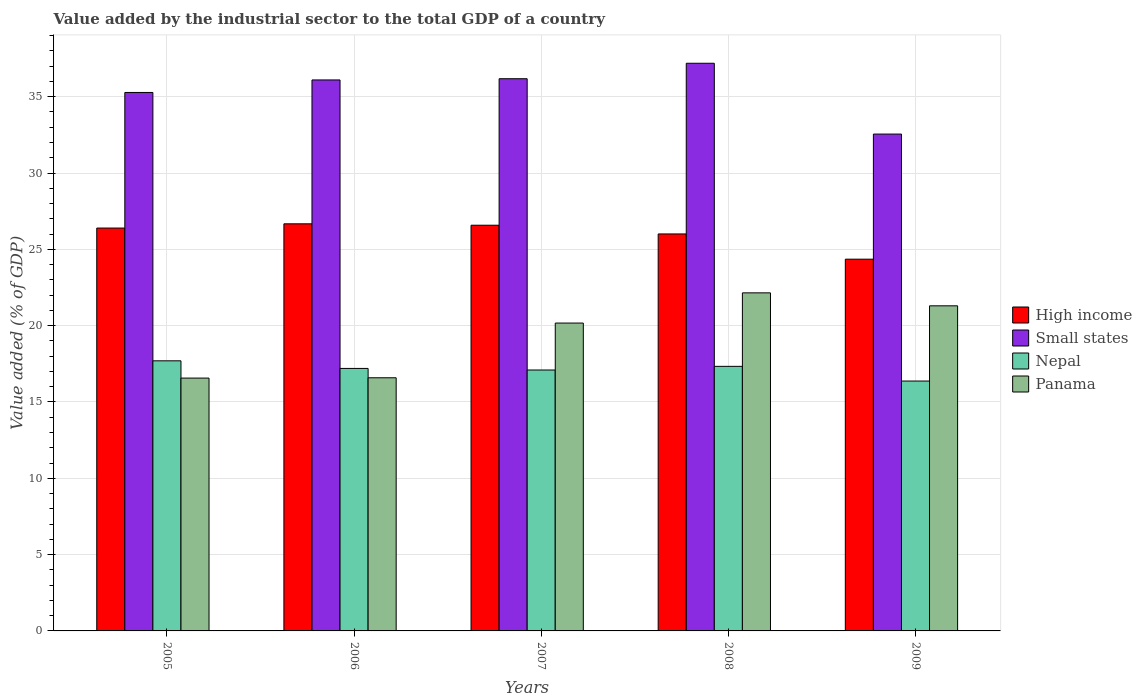How many different coloured bars are there?
Make the answer very short. 4. How many groups of bars are there?
Your answer should be very brief. 5. Are the number of bars per tick equal to the number of legend labels?
Your answer should be compact. Yes. Are the number of bars on each tick of the X-axis equal?
Make the answer very short. Yes. How many bars are there on the 1st tick from the left?
Your response must be concise. 4. What is the label of the 3rd group of bars from the left?
Provide a succinct answer. 2007. What is the value added by the industrial sector to the total GDP in Nepal in 2006?
Your response must be concise. 17.2. Across all years, what is the maximum value added by the industrial sector to the total GDP in Panama?
Give a very brief answer. 22.15. Across all years, what is the minimum value added by the industrial sector to the total GDP in Small states?
Offer a terse response. 32.55. In which year was the value added by the industrial sector to the total GDP in Small states maximum?
Your answer should be very brief. 2008. In which year was the value added by the industrial sector to the total GDP in High income minimum?
Give a very brief answer. 2009. What is the total value added by the industrial sector to the total GDP in Panama in the graph?
Ensure brevity in your answer.  96.77. What is the difference between the value added by the industrial sector to the total GDP in Panama in 2006 and that in 2009?
Your answer should be very brief. -4.71. What is the difference between the value added by the industrial sector to the total GDP in Panama in 2007 and the value added by the industrial sector to the total GDP in High income in 2005?
Offer a terse response. -6.22. What is the average value added by the industrial sector to the total GDP in High income per year?
Offer a very short reply. 26. In the year 2007, what is the difference between the value added by the industrial sector to the total GDP in Panama and value added by the industrial sector to the total GDP in High income?
Offer a terse response. -6.41. What is the ratio of the value added by the industrial sector to the total GDP in High income in 2006 to that in 2007?
Give a very brief answer. 1. Is the difference between the value added by the industrial sector to the total GDP in Panama in 2006 and 2009 greater than the difference between the value added by the industrial sector to the total GDP in High income in 2006 and 2009?
Your answer should be very brief. No. What is the difference between the highest and the second highest value added by the industrial sector to the total GDP in Small states?
Your answer should be very brief. 1.01. What is the difference between the highest and the lowest value added by the industrial sector to the total GDP in High income?
Provide a short and direct response. 2.32. In how many years, is the value added by the industrial sector to the total GDP in High income greater than the average value added by the industrial sector to the total GDP in High income taken over all years?
Provide a succinct answer. 4. Is the sum of the value added by the industrial sector to the total GDP in Panama in 2006 and 2009 greater than the maximum value added by the industrial sector to the total GDP in Nepal across all years?
Provide a short and direct response. Yes. What does the 3rd bar from the left in 2009 represents?
Your response must be concise. Nepal. What does the 3rd bar from the right in 2005 represents?
Offer a terse response. Small states. How many bars are there?
Offer a terse response. 20. How many years are there in the graph?
Keep it short and to the point. 5. Are the values on the major ticks of Y-axis written in scientific E-notation?
Your answer should be compact. No. Does the graph contain any zero values?
Offer a very short reply. No. Does the graph contain grids?
Keep it short and to the point. Yes. Where does the legend appear in the graph?
Offer a very short reply. Center right. How are the legend labels stacked?
Offer a terse response. Vertical. What is the title of the graph?
Your response must be concise. Value added by the industrial sector to the total GDP of a country. Does "Ethiopia" appear as one of the legend labels in the graph?
Your response must be concise. No. What is the label or title of the X-axis?
Keep it short and to the point. Years. What is the label or title of the Y-axis?
Make the answer very short. Value added (% of GDP). What is the Value added (% of GDP) of High income in 2005?
Offer a very short reply. 26.39. What is the Value added (% of GDP) of Small states in 2005?
Make the answer very short. 35.28. What is the Value added (% of GDP) of Nepal in 2005?
Make the answer very short. 17.7. What is the Value added (% of GDP) of Panama in 2005?
Offer a terse response. 16.56. What is the Value added (% of GDP) of High income in 2006?
Give a very brief answer. 26.67. What is the Value added (% of GDP) of Small states in 2006?
Provide a short and direct response. 36.1. What is the Value added (% of GDP) in Nepal in 2006?
Give a very brief answer. 17.2. What is the Value added (% of GDP) in Panama in 2006?
Provide a succinct answer. 16.58. What is the Value added (% of GDP) in High income in 2007?
Offer a terse response. 26.58. What is the Value added (% of GDP) in Small states in 2007?
Your answer should be compact. 36.18. What is the Value added (% of GDP) in Nepal in 2007?
Offer a very short reply. 17.09. What is the Value added (% of GDP) of Panama in 2007?
Make the answer very short. 20.17. What is the Value added (% of GDP) in High income in 2008?
Your answer should be compact. 26.01. What is the Value added (% of GDP) of Small states in 2008?
Offer a very short reply. 37.19. What is the Value added (% of GDP) of Nepal in 2008?
Keep it short and to the point. 17.33. What is the Value added (% of GDP) of Panama in 2008?
Provide a short and direct response. 22.15. What is the Value added (% of GDP) of High income in 2009?
Provide a succinct answer. 24.35. What is the Value added (% of GDP) in Small states in 2009?
Offer a very short reply. 32.55. What is the Value added (% of GDP) of Nepal in 2009?
Offer a very short reply. 16.37. What is the Value added (% of GDP) in Panama in 2009?
Keep it short and to the point. 21.3. Across all years, what is the maximum Value added (% of GDP) in High income?
Offer a terse response. 26.67. Across all years, what is the maximum Value added (% of GDP) in Small states?
Ensure brevity in your answer.  37.19. Across all years, what is the maximum Value added (% of GDP) of Nepal?
Provide a succinct answer. 17.7. Across all years, what is the maximum Value added (% of GDP) of Panama?
Ensure brevity in your answer.  22.15. Across all years, what is the minimum Value added (% of GDP) in High income?
Keep it short and to the point. 24.35. Across all years, what is the minimum Value added (% of GDP) of Small states?
Ensure brevity in your answer.  32.55. Across all years, what is the minimum Value added (% of GDP) in Nepal?
Make the answer very short. 16.37. Across all years, what is the minimum Value added (% of GDP) in Panama?
Your answer should be very brief. 16.56. What is the total Value added (% of GDP) of High income in the graph?
Your answer should be very brief. 130.01. What is the total Value added (% of GDP) in Small states in the graph?
Ensure brevity in your answer.  177.3. What is the total Value added (% of GDP) of Nepal in the graph?
Offer a terse response. 85.69. What is the total Value added (% of GDP) in Panama in the graph?
Make the answer very short. 96.77. What is the difference between the Value added (% of GDP) in High income in 2005 and that in 2006?
Offer a very short reply. -0.28. What is the difference between the Value added (% of GDP) of Small states in 2005 and that in 2006?
Offer a terse response. -0.82. What is the difference between the Value added (% of GDP) of Nepal in 2005 and that in 2006?
Your response must be concise. 0.5. What is the difference between the Value added (% of GDP) in Panama in 2005 and that in 2006?
Keep it short and to the point. -0.02. What is the difference between the Value added (% of GDP) in High income in 2005 and that in 2007?
Ensure brevity in your answer.  -0.19. What is the difference between the Value added (% of GDP) of Small states in 2005 and that in 2007?
Give a very brief answer. -0.9. What is the difference between the Value added (% of GDP) in Nepal in 2005 and that in 2007?
Make the answer very short. 0.6. What is the difference between the Value added (% of GDP) in Panama in 2005 and that in 2007?
Provide a succinct answer. -3.61. What is the difference between the Value added (% of GDP) in High income in 2005 and that in 2008?
Your answer should be very brief. 0.39. What is the difference between the Value added (% of GDP) in Small states in 2005 and that in 2008?
Your answer should be very brief. -1.91. What is the difference between the Value added (% of GDP) of Nepal in 2005 and that in 2008?
Offer a terse response. 0.36. What is the difference between the Value added (% of GDP) of Panama in 2005 and that in 2008?
Offer a terse response. -5.58. What is the difference between the Value added (% of GDP) of High income in 2005 and that in 2009?
Ensure brevity in your answer.  2.04. What is the difference between the Value added (% of GDP) of Small states in 2005 and that in 2009?
Offer a terse response. 2.73. What is the difference between the Value added (% of GDP) of Nepal in 2005 and that in 2009?
Provide a short and direct response. 1.32. What is the difference between the Value added (% of GDP) of Panama in 2005 and that in 2009?
Provide a short and direct response. -4.73. What is the difference between the Value added (% of GDP) in High income in 2006 and that in 2007?
Your response must be concise. 0.09. What is the difference between the Value added (% of GDP) of Small states in 2006 and that in 2007?
Provide a succinct answer. -0.08. What is the difference between the Value added (% of GDP) of Nepal in 2006 and that in 2007?
Provide a short and direct response. 0.1. What is the difference between the Value added (% of GDP) of Panama in 2006 and that in 2007?
Your answer should be compact. -3.59. What is the difference between the Value added (% of GDP) of High income in 2006 and that in 2008?
Your answer should be very brief. 0.66. What is the difference between the Value added (% of GDP) in Small states in 2006 and that in 2008?
Ensure brevity in your answer.  -1.09. What is the difference between the Value added (% of GDP) in Nepal in 2006 and that in 2008?
Offer a very short reply. -0.14. What is the difference between the Value added (% of GDP) of Panama in 2006 and that in 2008?
Offer a terse response. -5.56. What is the difference between the Value added (% of GDP) of High income in 2006 and that in 2009?
Your answer should be very brief. 2.32. What is the difference between the Value added (% of GDP) in Small states in 2006 and that in 2009?
Offer a very short reply. 3.55. What is the difference between the Value added (% of GDP) of Nepal in 2006 and that in 2009?
Offer a very short reply. 0.83. What is the difference between the Value added (% of GDP) of Panama in 2006 and that in 2009?
Your answer should be compact. -4.71. What is the difference between the Value added (% of GDP) in High income in 2007 and that in 2008?
Provide a short and direct response. 0.57. What is the difference between the Value added (% of GDP) in Small states in 2007 and that in 2008?
Provide a succinct answer. -1.01. What is the difference between the Value added (% of GDP) in Nepal in 2007 and that in 2008?
Your answer should be compact. -0.24. What is the difference between the Value added (% of GDP) of Panama in 2007 and that in 2008?
Your answer should be very brief. -1.98. What is the difference between the Value added (% of GDP) of High income in 2007 and that in 2009?
Your answer should be compact. 2.23. What is the difference between the Value added (% of GDP) of Small states in 2007 and that in 2009?
Give a very brief answer. 3.63. What is the difference between the Value added (% of GDP) in Nepal in 2007 and that in 2009?
Offer a terse response. 0.72. What is the difference between the Value added (% of GDP) in Panama in 2007 and that in 2009?
Your response must be concise. -1.13. What is the difference between the Value added (% of GDP) of High income in 2008 and that in 2009?
Ensure brevity in your answer.  1.65. What is the difference between the Value added (% of GDP) of Small states in 2008 and that in 2009?
Your answer should be very brief. 4.64. What is the difference between the Value added (% of GDP) of Nepal in 2008 and that in 2009?
Offer a terse response. 0.96. What is the difference between the Value added (% of GDP) in Panama in 2008 and that in 2009?
Ensure brevity in your answer.  0.85. What is the difference between the Value added (% of GDP) in High income in 2005 and the Value added (% of GDP) in Small states in 2006?
Provide a short and direct response. -9.7. What is the difference between the Value added (% of GDP) of High income in 2005 and the Value added (% of GDP) of Nepal in 2006?
Make the answer very short. 9.2. What is the difference between the Value added (% of GDP) in High income in 2005 and the Value added (% of GDP) in Panama in 2006?
Ensure brevity in your answer.  9.81. What is the difference between the Value added (% of GDP) in Small states in 2005 and the Value added (% of GDP) in Nepal in 2006?
Your answer should be compact. 18.08. What is the difference between the Value added (% of GDP) of Small states in 2005 and the Value added (% of GDP) of Panama in 2006?
Ensure brevity in your answer.  18.69. What is the difference between the Value added (% of GDP) in Nepal in 2005 and the Value added (% of GDP) in Panama in 2006?
Offer a very short reply. 1.11. What is the difference between the Value added (% of GDP) of High income in 2005 and the Value added (% of GDP) of Small states in 2007?
Provide a short and direct response. -9.78. What is the difference between the Value added (% of GDP) of High income in 2005 and the Value added (% of GDP) of Nepal in 2007?
Your answer should be very brief. 9.3. What is the difference between the Value added (% of GDP) of High income in 2005 and the Value added (% of GDP) of Panama in 2007?
Offer a very short reply. 6.22. What is the difference between the Value added (% of GDP) in Small states in 2005 and the Value added (% of GDP) in Nepal in 2007?
Your answer should be very brief. 18.18. What is the difference between the Value added (% of GDP) of Small states in 2005 and the Value added (% of GDP) of Panama in 2007?
Your response must be concise. 15.11. What is the difference between the Value added (% of GDP) of Nepal in 2005 and the Value added (% of GDP) of Panama in 2007?
Your answer should be compact. -2.47. What is the difference between the Value added (% of GDP) in High income in 2005 and the Value added (% of GDP) in Small states in 2008?
Offer a terse response. -10.8. What is the difference between the Value added (% of GDP) in High income in 2005 and the Value added (% of GDP) in Nepal in 2008?
Your answer should be compact. 9.06. What is the difference between the Value added (% of GDP) in High income in 2005 and the Value added (% of GDP) in Panama in 2008?
Ensure brevity in your answer.  4.25. What is the difference between the Value added (% of GDP) in Small states in 2005 and the Value added (% of GDP) in Nepal in 2008?
Offer a very short reply. 17.94. What is the difference between the Value added (% of GDP) in Small states in 2005 and the Value added (% of GDP) in Panama in 2008?
Your answer should be very brief. 13.13. What is the difference between the Value added (% of GDP) of Nepal in 2005 and the Value added (% of GDP) of Panama in 2008?
Make the answer very short. -4.45. What is the difference between the Value added (% of GDP) in High income in 2005 and the Value added (% of GDP) in Small states in 2009?
Your answer should be very brief. -6.16. What is the difference between the Value added (% of GDP) in High income in 2005 and the Value added (% of GDP) in Nepal in 2009?
Ensure brevity in your answer.  10.02. What is the difference between the Value added (% of GDP) of High income in 2005 and the Value added (% of GDP) of Panama in 2009?
Provide a succinct answer. 5.1. What is the difference between the Value added (% of GDP) in Small states in 2005 and the Value added (% of GDP) in Nepal in 2009?
Your answer should be compact. 18.91. What is the difference between the Value added (% of GDP) of Small states in 2005 and the Value added (% of GDP) of Panama in 2009?
Ensure brevity in your answer.  13.98. What is the difference between the Value added (% of GDP) of Nepal in 2005 and the Value added (% of GDP) of Panama in 2009?
Offer a very short reply. -3.6. What is the difference between the Value added (% of GDP) in High income in 2006 and the Value added (% of GDP) in Small states in 2007?
Give a very brief answer. -9.51. What is the difference between the Value added (% of GDP) of High income in 2006 and the Value added (% of GDP) of Nepal in 2007?
Provide a short and direct response. 9.58. What is the difference between the Value added (% of GDP) of High income in 2006 and the Value added (% of GDP) of Panama in 2007?
Make the answer very short. 6.5. What is the difference between the Value added (% of GDP) in Small states in 2006 and the Value added (% of GDP) in Nepal in 2007?
Your answer should be very brief. 19. What is the difference between the Value added (% of GDP) of Small states in 2006 and the Value added (% of GDP) of Panama in 2007?
Provide a succinct answer. 15.93. What is the difference between the Value added (% of GDP) of Nepal in 2006 and the Value added (% of GDP) of Panama in 2007?
Provide a succinct answer. -2.97. What is the difference between the Value added (% of GDP) of High income in 2006 and the Value added (% of GDP) of Small states in 2008?
Offer a terse response. -10.52. What is the difference between the Value added (% of GDP) of High income in 2006 and the Value added (% of GDP) of Nepal in 2008?
Give a very brief answer. 9.34. What is the difference between the Value added (% of GDP) of High income in 2006 and the Value added (% of GDP) of Panama in 2008?
Provide a succinct answer. 4.52. What is the difference between the Value added (% of GDP) in Small states in 2006 and the Value added (% of GDP) in Nepal in 2008?
Your answer should be compact. 18.76. What is the difference between the Value added (% of GDP) in Small states in 2006 and the Value added (% of GDP) in Panama in 2008?
Ensure brevity in your answer.  13.95. What is the difference between the Value added (% of GDP) in Nepal in 2006 and the Value added (% of GDP) in Panama in 2008?
Your answer should be very brief. -4.95. What is the difference between the Value added (% of GDP) in High income in 2006 and the Value added (% of GDP) in Small states in 2009?
Provide a short and direct response. -5.88. What is the difference between the Value added (% of GDP) in High income in 2006 and the Value added (% of GDP) in Nepal in 2009?
Provide a succinct answer. 10.3. What is the difference between the Value added (% of GDP) of High income in 2006 and the Value added (% of GDP) of Panama in 2009?
Your response must be concise. 5.37. What is the difference between the Value added (% of GDP) in Small states in 2006 and the Value added (% of GDP) in Nepal in 2009?
Your answer should be compact. 19.73. What is the difference between the Value added (% of GDP) in Small states in 2006 and the Value added (% of GDP) in Panama in 2009?
Offer a terse response. 14.8. What is the difference between the Value added (% of GDP) in Nepal in 2006 and the Value added (% of GDP) in Panama in 2009?
Provide a short and direct response. -4.1. What is the difference between the Value added (% of GDP) in High income in 2007 and the Value added (% of GDP) in Small states in 2008?
Your response must be concise. -10.61. What is the difference between the Value added (% of GDP) in High income in 2007 and the Value added (% of GDP) in Nepal in 2008?
Offer a very short reply. 9.25. What is the difference between the Value added (% of GDP) in High income in 2007 and the Value added (% of GDP) in Panama in 2008?
Provide a succinct answer. 4.43. What is the difference between the Value added (% of GDP) of Small states in 2007 and the Value added (% of GDP) of Nepal in 2008?
Offer a very short reply. 18.84. What is the difference between the Value added (% of GDP) of Small states in 2007 and the Value added (% of GDP) of Panama in 2008?
Give a very brief answer. 14.03. What is the difference between the Value added (% of GDP) of Nepal in 2007 and the Value added (% of GDP) of Panama in 2008?
Provide a succinct answer. -5.06. What is the difference between the Value added (% of GDP) in High income in 2007 and the Value added (% of GDP) in Small states in 2009?
Keep it short and to the point. -5.97. What is the difference between the Value added (% of GDP) of High income in 2007 and the Value added (% of GDP) of Nepal in 2009?
Make the answer very short. 10.21. What is the difference between the Value added (% of GDP) in High income in 2007 and the Value added (% of GDP) in Panama in 2009?
Your answer should be very brief. 5.28. What is the difference between the Value added (% of GDP) of Small states in 2007 and the Value added (% of GDP) of Nepal in 2009?
Give a very brief answer. 19.81. What is the difference between the Value added (% of GDP) of Small states in 2007 and the Value added (% of GDP) of Panama in 2009?
Keep it short and to the point. 14.88. What is the difference between the Value added (% of GDP) in Nepal in 2007 and the Value added (% of GDP) in Panama in 2009?
Your answer should be very brief. -4.21. What is the difference between the Value added (% of GDP) of High income in 2008 and the Value added (% of GDP) of Small states in 2009?
Your answer should be very brief. -6.54. What is the difference between the Value added (% of GDP) in High income in 2008 and the Value added (% of GDP) in Nepal in 2009?
Make the answer very short. 9.64. What is the difference between the Value added (% of GDP) of High income in 2008 and the Value added (% of GDP) of Panama in 2009?
Offer a very short reply. 4.71. What is the difference between the Value added (% of GDP) of Small states in 2008 and the Value added (% of GDP) of Nepal in 2009?
Keep it short and to the point. 20.82. What is the difference between the Value added (% of GDP) of Small states in 2008 and the Value added (% of GDP) of Panama in 2009?
Ensure brevity in your answer.  15.89. What is the difference between the Value added (% of GDP) of Nepal in 2008 and the Value added (% of GDP) of Panama in 2009?
Your answer should be compact. -3.97. What is the average Value added (% of GDP) in High income per year?
Give a very brief answer. 26. What is the average Value added (% of GDP) in Small states per year?
Ensure brevity in your answer.  35.46. What is the average Value added (% of GDP) in Nepal per year?
Ensure brevity in your answer.  17.14. What is the average Value added (% of GDP) in Panama per year?
Offer a very short reply. 19.35. In the year 2005, what is the difference between the Value added (% of GDP) of High income and Value added (% of GDP) of Small states?
Your answer should be very brief. -8.88. In the year 2005, what is the difference between the Value added (% of GDP) in High income and Value added (% of GDP) in Nepal?
Give a very brief answer. 8.7. In the year 2005, what is the difference between the Value added (% of GDP) of High income and Value added (% of GDP) of Panama?
Provide a succinct answer. 9.83. In the year 2005, what is the difference between the Value added (% of GDP) in Small states and Value added (% of GDP) in Nepal?
Make the answer very short. 17.58. In the year 2005, what is the difference between the Value added (% of GDP) in Small states and Value added (% of GDP) in Panama?
Your answer should be very brief. 18.71. In the year 2005, what is the difference between the Value added (% of GDP) of Nepal and Value added (% of GDP) of Panama?
Keep it short and to the point. 1.13. In the year 2006, what is the difference between the Value added (% of GDP) of High income and Value added (% of GDP) of Small states?
Your answer should be very brief. -9.43. In the year 2006, what is the difference between the Value added (% of GDP) in High income and Value added (% of GDP) in Nepal?
Offer a very short reply. 9.47. In the year 2006, what is the difference between the Value added (% of GDP) of High income and Value added (% of GDP) of Panama?
Your answer should be compact. 10.09. In the year 2006, what is the difference between the Value added (% of GDP) in Small states and Value added (% of GDP) in Nepal?
Provide a succinct answer. 18.9. In the year 2006, what is the difference between the Value added (% of GDP) of Small states and Value added (% of GDP) of Panama?
Offer a terse response. 19.51. In the year 2006, what is the difference between the Value added (% of GDP) in Nepal and Value added (% of GDP) in Panama?
Offer a terse response. 0.61. In the year 2007, what is the difference between the Value added (% of GDP) of High income and Value added (% of GDP) of Small states?
Provide a succinct answer. -9.6. In the year 2007, what is the difference between the Value added (% of GDP) of High income and Value added (% of GDP) of Nepal?
Keep it short and to the point. 9.49. In the year 2007, what is the difference between the Value added (% of GDP) in High income and Value added (% of GDP) in Panama?
Your answer should be compact. 6.41. In the year 2007, what is the difference between the Value added (% of GDP) in Small states and Value added (% of GDP) in Nepal?
Your answer should be compact. 19.08. In the year 2007, what is the difference between the Value added (% of GDP) in Small states and Value added (% of GDP) in Panama?
Keep it short and to the point. 16.01. In the year 2007, what is the difference between the Value added (% of GDP) of Nepal and Value added (% of GDP) of Panama?
Ensure brevity in your answer.  -3.08. In the year 2008, what is the difference between the Value added (% of GDP) in High income and Value added (% of GDP) in Small states?
Your response must be concise. -11.18. In the year 2008, what is the difference between the Value added (% of GDP) of High income and Value added (% of GDP) of Nepal?
Give a very brief answer. 8.67. In the year 2008, what is the difference between the Value added (% of GDP) in High income and Value added (% of GDP) in Panama?
Offer a very short reply. 3.86. In the year 2008, what is the difference between the Value added (% of GDP) in Small states and Value added (% of GDP) in Nepal?
Your answer should be compact. 19.86. In the year 2008, what is the difference between the Value added (% of GDP) in Small states and Value added (% of GDP) in Panama?
Your answer should be very brief. 15.04. In the year 2008, what is the difference between the Value added (% of GDP) of Nepal and Value added (% of GDP) of Panama?
Offer a terse response. -4.82. In the year 2009, what is the difference between the Value added (% of GDP) of High income and Value added (% of GDP) of Small states?
Keep it short and to the point. -8.2. In the year 2009, what is the difference between the Value added (% of GDP) of High income and Value added (% of GDP) of Nepal?
Make the answer very short. 7.98. In the year 2009, what is the difference between the Value added (% of GDP) of High income and Value added (% of GDP) of Panama?
Ensure brevity in your answer.  3.06. In the year 2009, what is the difference between the Value added (% of GDP) of Small states and Value added (% of GDP) of Nepal?
Keep it short and to the point. 16.18. In the year 2009, what is the difference between the Value added (% of GDP) of Small states and Value added (% of GDP) of Panama?
Provide a short and direct response. 11.25. In the year 2009, what is the difference between the Value added (% of GDP) of Nepal and Value added (% of GDP) of Panama?
Offer a very short reply. -4.93. What is the ratio of the Value added (% of GDP) in Small states in 2005 to that in 2006?
Your response must be concise. 0.98. What is the ratio of the Value added (% of GDP) of Panama in 2005 to that in 2006?
Give a very brief answer. 1. What is the ratio of the Value added (% of GDP) in High income in 2005 to that in 2007?
Provide a succinct answer. 0.99. What is the ratio of the Value added (% of GDP) in Small states in 2005 to that in 2007?
Your answer should be compact. 0.98. What is the ratio of the Value added (% of GDP) in Nepal in 2005 to that in 2007?
Offer a very short reply. 1.04. What is the ratio of the Value added (% of GDP) of Panama in 2005 to that in 2007?
Your response must be concise. 0.82. What is the ratio of the Value added (% of GDP) in High income in 2005 to that in 2008?
Offer a very short reply. 1.01. What is the ratio of the Value added (% of GDP) of Small states in 2005 to that in 2008?
Offer a very short reply. 0.95. What is the ratio of the Value added (% of GDP) in Nepal in 2005 to that in 2008?
Your answer should be very brief. 1.02. What is the ratio of the Value added (% of GDP) of Panama in 2005 to that in 2008?
Your response must be concise. 0.75. What is the ratio of the Value added (% of GDP) in High income in 2005 to that in 2009?
Offer a very short reply. 1.08. What is the ratio of the Value added (% of GDP) of Small states in 2005 to that in 2009?
Provide a succinct answer. 1.08. What is the ratio of the Value added (% of GDP) of Nepal in 2005 to that in 2009?
Provide a short and direct response. 1.08. What is the ratio of the Value added (% of GDP) of Panama in 2005 to that in 2009?
Your answer should be very brief. 0.78. What is the ratio of the Value added (% of GDP) of Nepal in 2006 to that in 2007?
Make the answer very short. 1.01. What is the ratio of the Value added (% of GDP) in Panama in 2006 to that in 2007?
Your answer should be compact. 0.82. What is the ratio of the Value added (% of GDP) in High income in 2006 to that in 2008?
Keep it short and to the point. 1.03. What is the ratio of the Value added (% of GDP) in Small states in 2006 to that in 2008?
Ensure brevity in your answer.  0.97. What is the ratio of the Value added (% of GDP) of Nepal in 2006 to that in 2008?
Your answer should be very brief. 0.99. What is the ratio of the Value added (% of GDP) in Panama in 2006 to that in 2008?
Ensure brevity in your answer.  0.75. What is the ratio of the Value added (% of GDP) of High income in 2006 to that in 2009?
Offer a very short reply. 1.1. What is the ratio of the Value added (% of GDP) of Small states in 2006 to that in 2009?
Your answer should be very brief. 1.11. What is the ratio of the Value added (% of GDP) of Nepal in 2006 to that in 2009?
Keep it short and to the point. 1.05. What is the ratio of the Value added (% of GDP) in Panama in 2006 to that in 2009?
Provide a short and direct response. 0.78. What is the ratio of the Value added (% of GDP) of High income in 2007 to that in 2008?
Provide a short and direct response. 1.02. What is the ratio of the Value added (% of GDP) in Small states in 2007 to that in 2008?
Offer a very short reply. 0.97. What is the ratio of the Value added (% of GDP) of Nepal in 2007 to that in 2008?
Provide a succinct answer. 0.99. What is the ratio of the Value added (% of GDP) of Panama in 2007 to that in 2008?
Provide a short and direct response. 0.91. What is the ratio of the Value added (% of GDP) in High income in 2007 to that in 2009?
Keep it short and to the point. 1.09. What is the ratio of the Value added (% of GDP) of Small states in 2007 to that in 2009?
Make the answer very short. 1.11. What is the ratio of the Value added (% of GDP) of Nepal in 2007 to that in 2009?
Give a very brief answer. 1.04. What is the ratio of the Value added (% of GDP) in Panama in 2007 to that in 2009?
Keep it short and to the point. 0.95. What is the ratio of the Value added (% of GDP) in High income in 2008 to that in 2009?
Ensure brevity in your answer.  1.07. What is the ratio of the Value added (% of GDP) in Small states in 2008 to that in 2009?
Give a very brief answer. 1.14. What is the ratio of the Value added (% of GDP) of Nepal in 2008 to that in 2009?
Your response must be concise. 1.06. What is the ratio of the Value added (% of GDP) of Panama in 2008 to that in 2009?
Give a very brief answer. 1.04. What is the difference between the highest and the second highest Value added (% of GDP) of High income?
Your response must be concise. 0.09. What is the difference between the highest and the second highest Value added (% of GDP) of Small states?
Offer a very short reply. 1.01. What is the difference between the highest and the second highest Value added (% of GDP) in Nepal?
Your response must be concise. 0.36. What is the difference between the highest and the second highest Value added (% of GDP) in Panama?
Your answer should be compact. 0.85. What is the difference between the highest and the lowest Value added (% of GDP) in High income?
Ensure brevity in your answer.  2.32. What is the difference between the highest and the lowest Value added (% of GDP) in Small states?
Provide a short and direct response. 4.64. What is the difference between the highest and the lowest Value added (% of GDP) in Nepal?
Offer a very short reply. 1.32. What is the difference between the highest and the lowest Value added (% of GDP) in Panama?
Give a very brief answer. 5.58. 